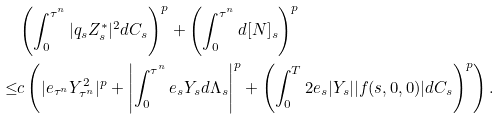<formula> <loc_0><loc_0><loc_500><loc_500>& \left ( \int _ { 0 } ^ { \tau ^ { n } } | q _ { s } Z _ { s } ^ { * } | ^ { 2 } d C _ { s } \right ) ^ { p } + \left ( \int _ { 0 } ^ { \tau ^ { n } } d [ N ] _ { s } \right ) ^ { p } \\ \leq & c \left ( | e _ { \tau ^ { n } } Y _ { \tau ^ { n } } ^ { 2 } | ^ { p } + \left | \int _ { 0 } ^ { \tau ^ { n } } e _ { s } Y _ { s } d \Lambda _ { s } \right | ^ { p } + \left ( \int _ { 0 } ^ { T } 2 e _ { s } | Y _ { s } | | f ( s , 0 , 0 ) | d C _ { s } \right ) ^ { p } \right ) .</formula> 